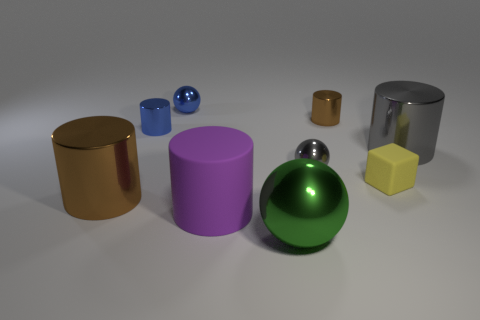Subtract all purple matte cylinders. How many cylinders are left? 4 Subtract all blue balls. How many balls are left? 2 Subtract all blocks. How many objects are left? 8 Subtract 1 balls. How many balls are left? 2 Subtract 1 green spheres. How many objects are left? 8 Subtract all brown blocks. Subtract all green spheres. How many blocks are left? 1 Subtract all purple cubes. How many green spheres are left? 1 Subtract all tiny blue metal objects. Subtract all large metal cylinders. How many objects are left? 5 Add 4 tiny brown metal things. How many tiny brown metal things are left? 5 Add 6 brown shiny cylinders. How many brown shiny cylinders exist? 8 